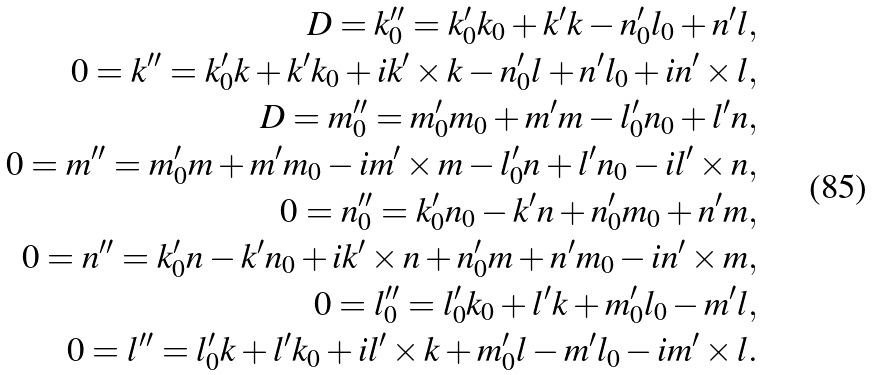<formula> <loc_0><loc_0><loc_500><loc_500>D = k _ { 0 } ^ { \prime \prime } = k _ { 0 } ^ { \prime } k _ { 0 } + { \boldsymbol k } ^ { \prime } { \boldsymbol k } - n ^ { \prime } _ { 0 } l _ { 0 } + { \boldsymbol n } ^ { \prime } { \boldsymbol l } , \\ 0 = { \boldsymbol k } ^ { \prime \prime } = k ^ { \prime } _ { 0 } { \boldsymbol k } + { \boldsymbol k } ^ { \prime } k _ { 0 } + i { \boldsymbol k } ^ { \prime } \times { \boldsymbol k } - n _ { 0 } ^ { \prime } { \boldsymbol l } + { \boldsymbol n } ^ { \prime } l _ { 0 } + i { \boldsymbol n } ^ { \prime } \times { \boldsymbol l } , \\ D = m _ { 0 } ^ { \prime \prime } = m _ { 0 } ^ { \prime } m _ { 0 } + { \boldsymbol m } ^ { \prime } { \boldsymbol m } - l ^ { \prime } _ { 0 } n _ { 0 } + { \boldsymbol l } ^ { \prime } { \boldsymbol n } , \\ 0 = { \boldsymbol m } ^ { \prime \prime } = m ^ { \prime } _ { 0 } { \boldsymbol m } + { \boldsymbol m } ^ { \prime } m _ { 0 } - i { \boldsymbol m } ^ { \prime } \times { \boldsymbol m } - l _ { 0 } ^ { \prime } { \boldsymbol n } + { \boldsymbol l } ^ { \prime } n _ { 0 } - i { \boldsymbol l } ^ { \prime } \times { \boldsymbol n } , \\ 0 = n _ { 0 } ^ { \prime \prime } = k _ { 0 } ^ { \prime } n _ { 0 } - { \boldsymbol k } ^ { \prime } { \boldsymbol n } + n ^ { \prime } _ { 0 } m _ { 0 } + { \boldsymbol n } ^ { \prime } { \boldsymbol m } , \\ 0 = { \boldsymbol n } ^ { \prime \prime } = k ^ { \prime } _ { 0 } { \boldsymbol n } - { \boldsymbol k } ^ { \prime } n _ { 0 } + i { \boldsymbol k } ^ { \prime } \times { \boldsymbol n } + n _ { 0 } ^ { \prime } { \boldsymbol m } + { \boldsymbol n } ^ { \prime } m _ { 0 } - i { \boldsymbol n } ^ { \prime } \times { \boldsymbol m } , \\ 0 = l _ { 0 } ^ { \prime \prime } = l _ { 0 } ^ { \prime } k _ { 0 } + { \boldsymbol l } ^ { \prime } { \boldsymbol k } + m ^ { \prime } _ { 0 } l _ { 0 } - { \boldsymbol m } ^ { \prime } { \boldsymbol l } , \\ 0 = { \boldsymbol l } ^ { \prime \prime } = l ^ { \prime } _ { 0 } { \boldsymbol k } + { \boldsymbol l } ^ { \prime } k _ { 0 } + i { \boldsymbol l } ^ { \prime } \times { \boldsymbol k } + m _ { 0 } ^ { \prime } { \boldsymbol l } - { \boldsymbol m } ^ { \prime } l _ { 0 } - i { \boldsymbol m } ^ { \prime } \times { \boldsymbol l } .</formula> 